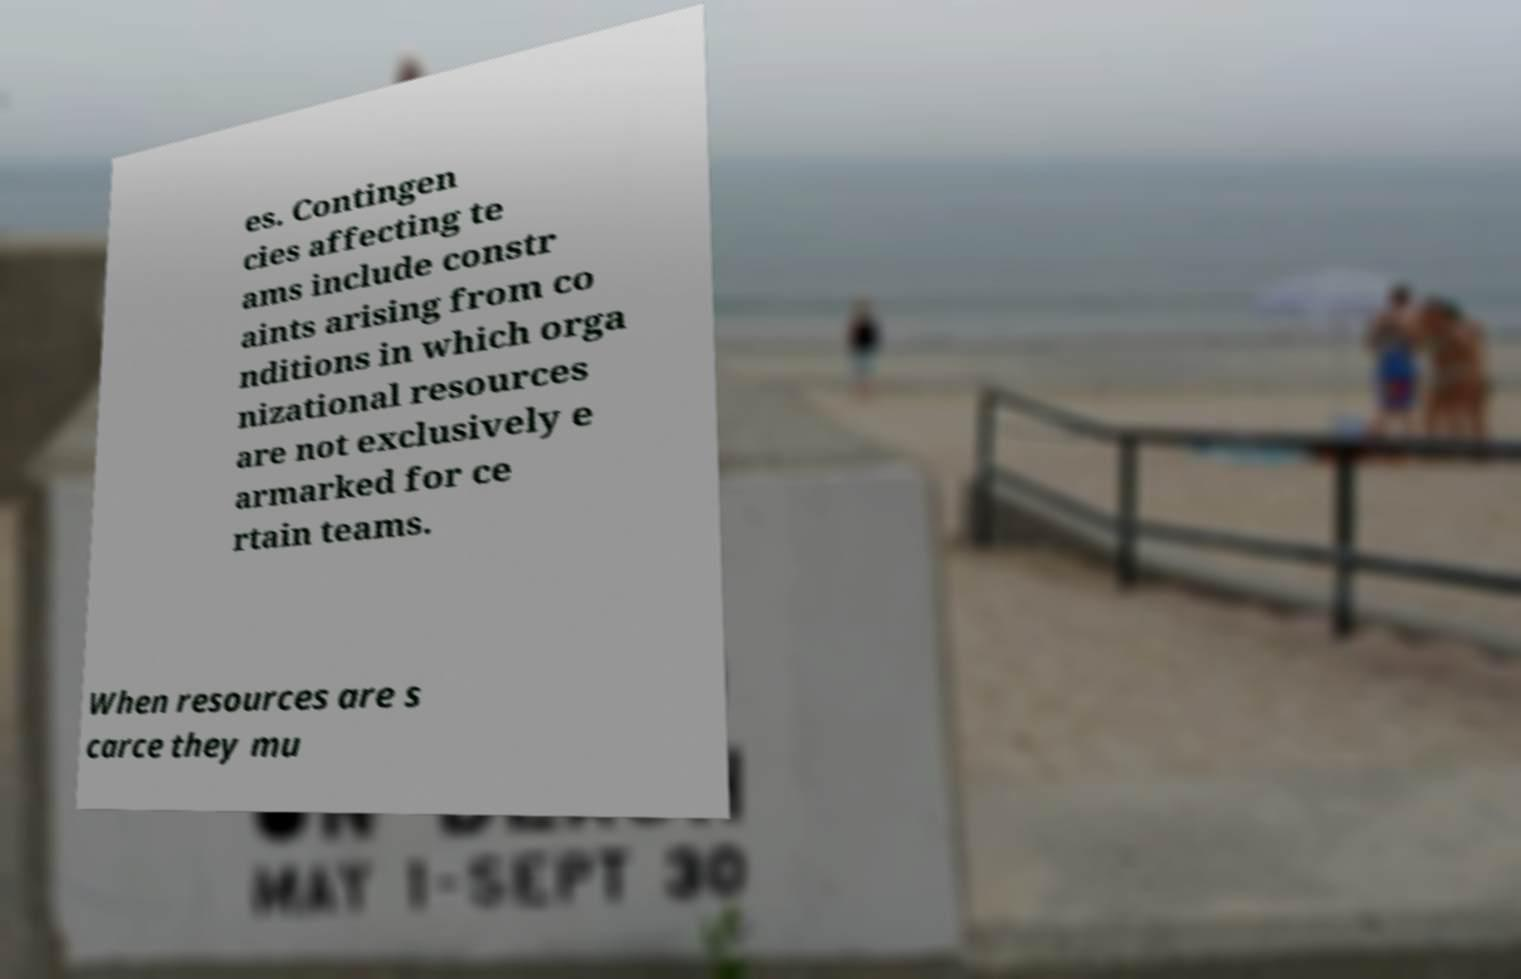Could you extract and type out the text from this image? es. Contingen cies affecting te ams include constr aints arising from co nditions in which orga nizational resources are not exclusively e armarked for ce rtain teams. When resources are s carce they mu 